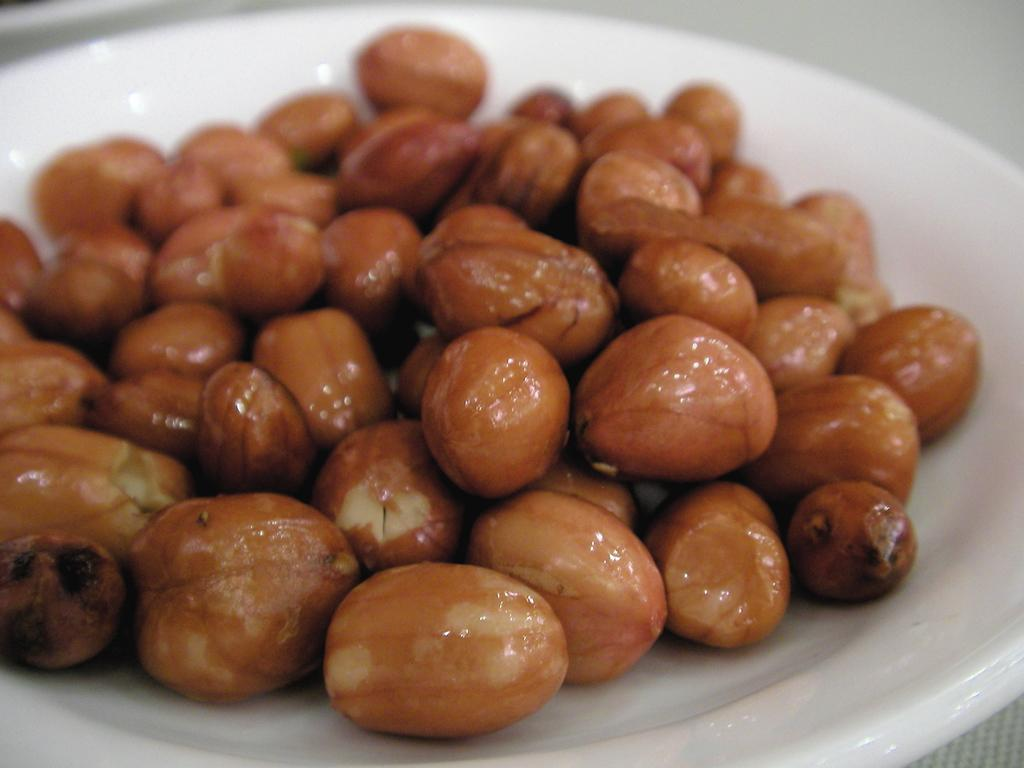What is on the plate in the image? There are food items on a plate in the image. Can you describe the background of the image? The background of the image is blurred. What type of town can be seen in the background of the image? There is no town visible in the image, as the background is blurred. What level of detail can be observed in the food items on the plate? The level of detail in the food items on the plate cannot be determined from the image, as the background is blurred. 